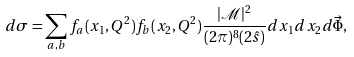<formula> <loc_0><loc_0><loc_500><loc_500>d \sigma = \sum _ { a , b } f _ { a } ( x _ { 1 } , Q ^ { 2 } ) f _ { b } ( x _ { 2 } , Q ^ { 2 } ) \frac { | { \mathcal { M } } | ^ { 2 } } { ( 2 \pi ) ^ { 8 } ( 2 \hat { s } ) } d x _ { 1 } d x _ { 2 } d \vec { \Phi } ,</formula> 